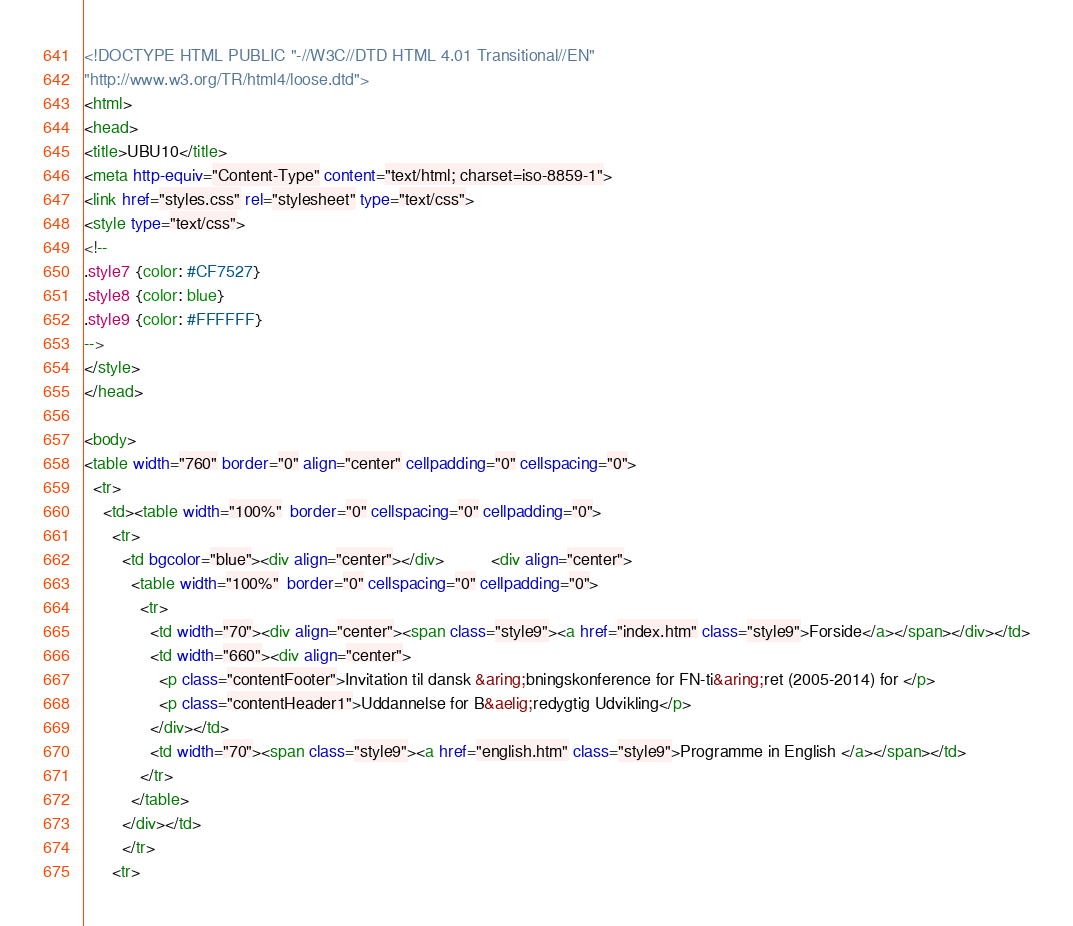<code> <loc_0><loc_0><loc_500><loc_500><_HTML_><!DOCTYPE HTML PUBLIC "-//W3C//DTD HTML 4.01 Transitional//EN"
"http://www.w3.org/TR/html4/loose.dtd">
<html>
<head>
<title>UBU10</title>
<meta http-equiv="Content-Type" content="text/html; charset=iso-8859-1">
<link href="styles.css" rel="stylesheet" type="text/css">
<style type="text/css">
<!--
.style7 {color: #CF7527}
.style8 {color: blue}
.style9 {color: #FFFFFF}
-->
</style>
</head>

<body>
<table width="760" border="0" align="center" cellpadding="0" cellspacing="0">
  <tr>
    <td><table width="100%"  border="0" cellspacing="0" cellpadding="0">
      <tr>
        <td bgcolor="blue"><div align="center"></div>          <div align="center">
          <table width="100%"  border="0" cellspacing="0" cellpadding="0">
            <tr>
              <td width="70"><div align="center"><span class="style9"><a href="index.htm" class="style9">Forside</a></span></div></td>
              <td width="660"><div align="center">
                <p class="contentFooter">Invitation til dansk &aring;bningskonference for FN-ti&aring;ret (2005-2014) for </p>
                <p class="contentHeader1">Uddannelse for B&aelig;redygtig Udvikling</p>
              </div></td>
              <td width="70"><span class="style9"><a href="english.htm" class="style9">Programme in English </a></span></td>
            </tr>
          </table>
        </div></td>
        </tr>
      <tr></code> 